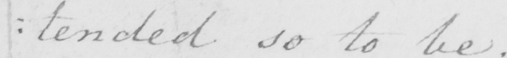What does this handwritten line say? : tended so to be . 